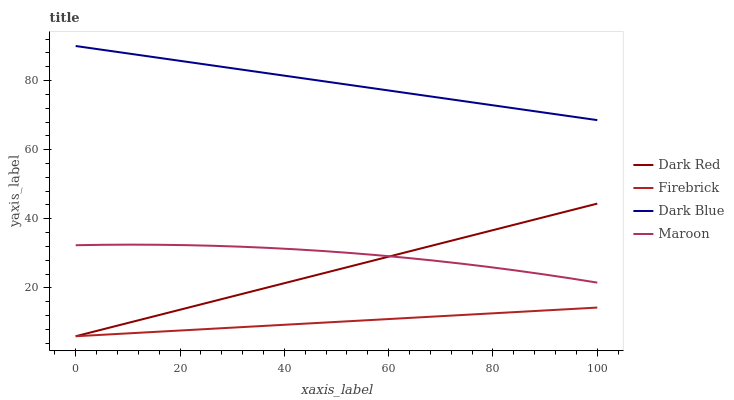Does Firebrick have the minimum area under the curve?
Answer yes or no. Yes. Does Dark Blue have the maximum area under the curve?
Answer yes or no. Yes. Does Maroon have the minimum area under the curve?
Answer yes or no. No. Does Maroon have the maximum area under the curve?
Answer yes or no. No. Is Firebrick the smoothest?
Answer yes or no. Yes. Is Maroon the roughest?
Answer yes or no. Yes. Is Maroon the smoothest?
Answer yes or no. No. Is Firebrick the roughest?
Answer yes or no. No. Does Dark Red have the lowest value?
Answer yes or no. Yes. Does Maroon have the lowest value?
Answer yes or no. No. Does Dark Blue have the highest value?
Answer yes or no. Yes. Does Maroon have the highest value?
Answer yes or no. No. Is Maroon less than Dark Blue?
Answer yes or no. Yes. Is Maroon greater than Firebrick?
Answer yes or no. Yes. Does Maroon intersect Dark Red?
Answer yes or no. Yes. Is Maroon less than Dark Red?
Answer yes or no. No. Is Maroon greater than Dark Red?
Answer yes or no. No. Does Maroon intersect Dark Blue?
Answer yes or no. No. 